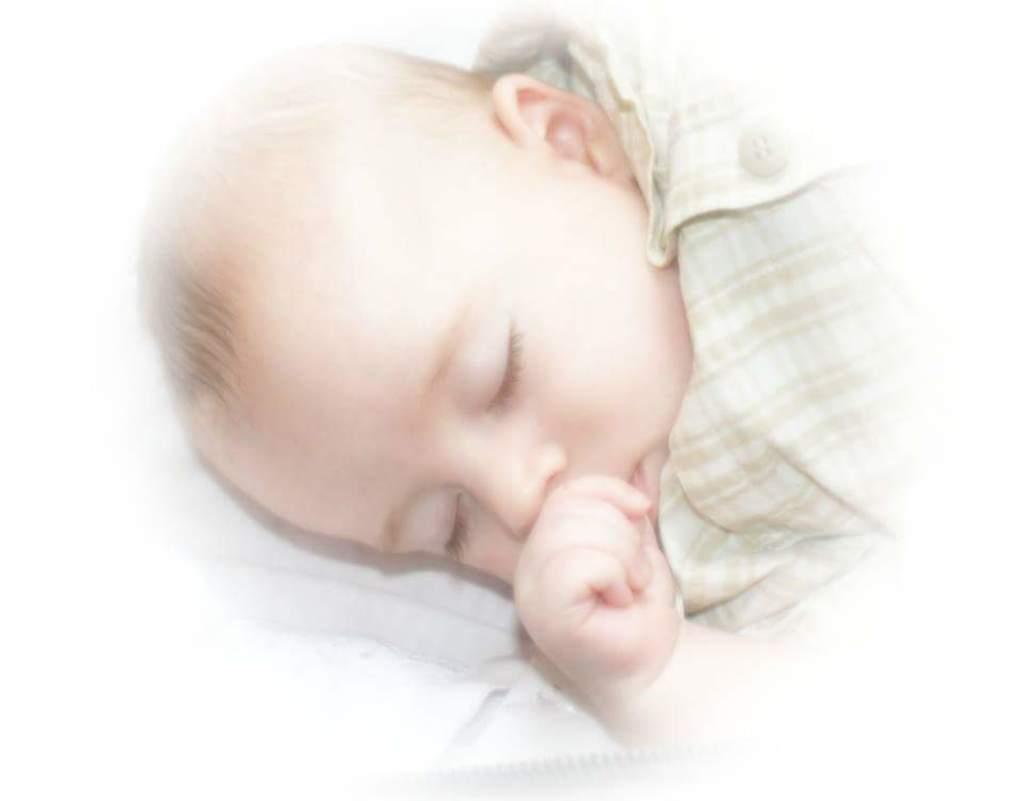Please provide a concise description of this image. In this picture we can see a baby and the baby is sleeping. 